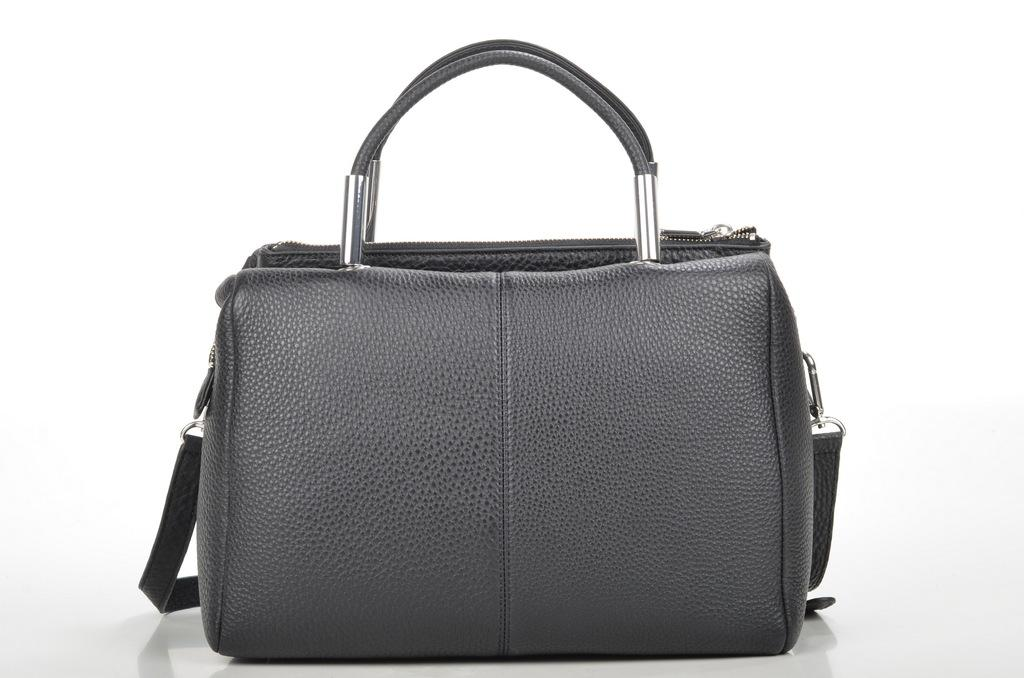What object can be seen in the image? There is a purse in the image. Can you describe the color of the purse? The purse is ash-colored. How many children are playing with a feather in the image? There are no children or feathers present in the image; it only features a purse. 